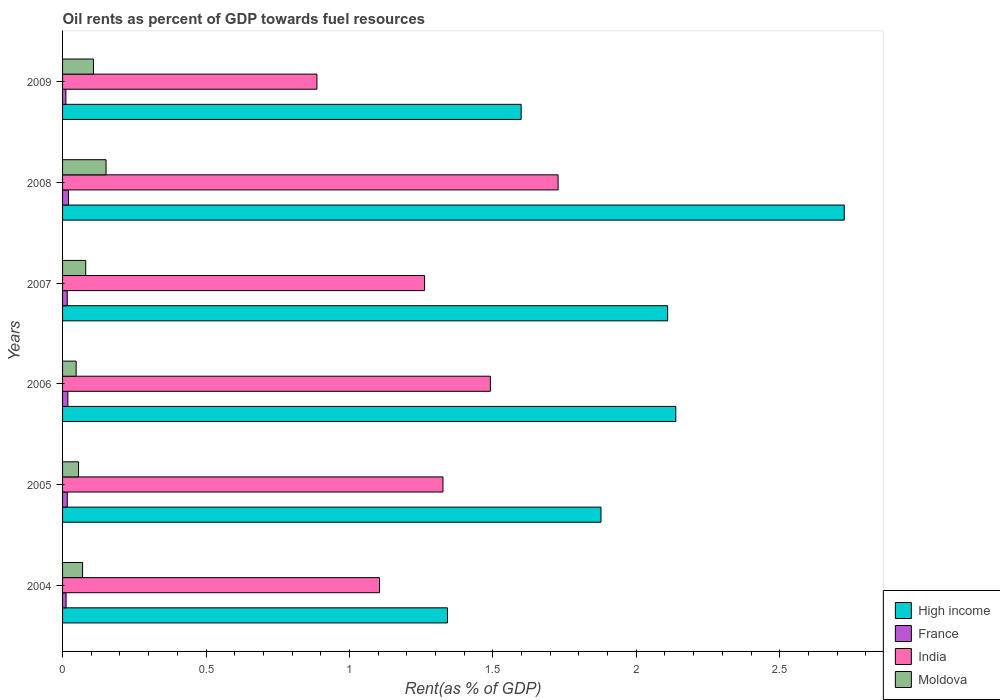Are the number of bars on each tick of the Y-axis equal?
Make the answer very short. Yes. How many bars are there on the 4th tick from the top?
Ensure brevity in your answer.  4. What is the label of the 2nd group of bars from the top?
Offer a very short reply. 2008. In how many cases, is the number of bars for a given year not equal to the number of legend labels?
Your answer should be very brief. 0. What is the oil rent in Moldova in 2004?
Ensure brevity in your answer.  0.07. Across all years, what is the maximum oil rent in Moldova?
Ensure brevity in your answer.  0.15. Across all years, what is the minimum oil rent in High income?
Offer a very short reply. 1.34. What is the total oil rent in India in the graph?
Your answer should be compact. 7.8. What is the difference between the oil rent in High income in 2007 and that in 2009?
Your answer should be very brief. 0.51. What is the difference between the oil rent in High income in 2009 and the oil rent in France in 2008?
Make the answer very short. 1.58. What is the average oil rent in Moldova per year?
Provide a short and direct response. 0.09. In the year 2006, what is the difference between the oil rent in High income and oil rent in France?
Your answer should be compact. 2.12. In how many years, is the oil rent in High income greater than 2.6 %?
Provide a short and direct response. 1. What is the ratio of the oil rent in Moldova in 2007 to that in 2008?
Provide a short and direct response. 0.53. Is the oil rent in India in 2006 less than that in 2009?
Give a very brief answer. No. What is the difference between the highest and the second highest oil rent in Moldova?
Offer a terse response. 0.04. What is the difference between the highest and the lowest oil rent in Moldova?
Your response must be concise. 0.1. Is it the case that in every year, the sum of the oil rent in India and oil rent in High income is greater than the sum of oil rent in Moldova and oil rent in France?
Your answer should be very brief. Yes. What does the 3rd bar from the top in 2009 represents?
Make the answer very short. France. Are all the bars in the graph horizontal?
Offer a very short reply. Yes. How many years are there in the graph?
Give a very brief answer. 6. What is the difference between two consecutive major ticks on the X-axis?
Ensure brevity in your answer.  0.5. Are the values on the major ticks of X-axis written in scientific E-notation?
Provide a short and direct response. No. Does the graph contain any zero values?
Offer a very short reply. No. Does the graph contain grids?
Your answer should be compact. No. How many legend labels are there?
Offer a very short reply. 4. How are the legend labels stacked?
Give a very brief answer. Vertical. What is the title of the graph?
Offer a terse response. Oil rents as percent of GDP towards fuel resources. What is the label or title of the X-axis?
Keep it short and to the point. Rent(as % of GDP). What is the label or title of the Y-axis?
Give a very brief answer. Years. What is the Rent(as % of GDP) of High income in 2004?
Your answer should be very brief. 1.34. What is the Rent(as % of GDP) of France in 2004?
Give a very brief answer. 0.01. What is the Rent(as % of GDP) in India in 2004?
Your response must be concise. 1.1. What is the Rent(as % of GDP) in Moldova in 2004?
Provide a short and direct response. 0.07. What is the Rent(as % of GDP) in High income in 2005?
Provide a succinct answer. 1.88. What is the Rent(as % of GDP) of France in 2005?
Ensure brevity in your answer.  0.02. What is the Rent(as % of GDP) of India in 2005?
Ensure brevity in your answer.  1.33. What is the Rent(as % of GDP) of Moldova in 2005?
Your response must be concise. 0.06. What is the Rent(as % of GDP) of High income in 2006?
Provide a succinct answer. 2.14. What is the Rent(as % of GDP) of France in 2006?
Your answer should be compact. 0.02. What is the Rent(as % of GDP) in India in 2006?
Provide a short and direct response. 1.49. What is the Rent(as % of GDP) in Moldova in 2006?
Ensure brevity in your answer.  0.05. What is the Rent(as % of GDP) in High income in 2007?
Offer a very short reply. 2.11. What is the Rent(as % of GDP) in France in 2007?
Provide a short and direct response. 0.02. What is the Rent(as % of GDP) of India in 2007?
Provide a succinct answer. 1.26. What is the Rent(as % of GDP) of Moldova in 2007?
Offer a terse response. 0.08. What is the Rent(as % of GDP) of High income in 2008?
Keep it short and to the point. 2.73. What is the Rent(as % of GDP) of France in 2008?
Provide a short and direct response. 0.02. What is the Rent(as % of GDP) in India in 2008?
Give a very brief answer. 1.73. What is the Rent(as % of GDP) of Moldova in 2008?
Offer a terse response. 0.15. What is the Rent(as % of GDP) in High income in 2009?
Offer a terse response. 1.6. What is the Rent(as % of GDP) of France in 2009?
Offer a very short reply. 0.01. What is the Rent(as % of GDP) in India in 2009?
Offer a very short reply. 0.89. What is the Rent(as % of GDP) of Moldova in 2009?
Your answer should be very brief. 0.11. Across all years, what is the maximum Rent(as % of GDP) of High income?
Your response must be concise. 2.73. Across all years, what is the maximum Rent(as % of GDP) in France?
Provide a succinct answer. 0.02. Across all years, what is the maximum Rent(as % of GDP) of India?
Provide a short and direct response. 1.73. Across all years, what is the maximum Rent(as % of GDP) of Moldova?
Keep it short and to the point. 0.15. Across all years, what is the minimum Rent(as % of GDP) in High income?
Make the answer very short. 1.34. Across all years, what is the minimum Rent(as % of GDP) of France?
Ensure brevity in your answer.  0.01. Across all years, what is the minimum Rent(as % of GDP) in India?
Give a very brief answer. 0.89. Across all years, what is the minimum Rent(as % of GDP) in Moldova?
Provide a succinct answer. 0.05. What is the total Rent(as % of GDP) in High income in the graph?
Your answer should be very brief. 11.79. What is the total Rent(as % of GDP) in France in the graph?
Your response must be concise. 0.1. What is the total Rent(as % of GDP) in India in the graph?
Give a very brief answer. 7.8. What is the total Rent(as % of GDP) in Moldova in the graph?
Provide a succinct answer. 0.51. What is the difference between the Rent(as % of GDP) of High income in 2004 and that in 2005?
Your answer should be compact. -0.54. What is the difference between the Rent(as % of GDP) in France in 2004 and that in 2005?
Offer a terse response. -0. What is the difference between the Rent(as % of GDP) of India in 2004 and that in 2005?
Your response must be concise. -0.22. What is the difference between the Rent(as % of GDP) of Moldova in 2004 and that in 2005?
Offer a terse response. 0.01. What is the difference between the Rent(as % of GDP) of High income in 2004 and that in 2006?
Your answer should be compact. -0.8. What is the difference between the Rent(as % of GDP) in France in 2004 and that in 2006?
Your response must be concise. -0.01. What is the difference between the Rent(as % of GDP) of India in 2004 and that in 2006?
Your answer should be very brief. -0.39. What is the difference between the Rent(as % of GDP) in Moldova in 2004 and that in 2006?
Provide a succinct answer. 0.02. What is the difference between the Rent(as % of GDP) in High income in 2004 and that in 2007?
Make the answer very short. -0.77. What is the difference between the Rent(as % of GDP) of France in 2004 and that in 2007?
Provide a short and direct response. -0. What is the difference between the Rent(as % of GDP) in India in 2004 and that in 2007?
Ensure brevity in your answer.  -0.16. What is the difference between the Rent(as % of GDP) in Moldova in 2004 and that in 2007?
Your answer should be compact. -0.01. What is the difference between the Rent(as % of GDP) of High income in 2004 and that in 2008?
Ensure brevity in your answer.  -1.38. What is the difference between the Rent(as % of GDP) of France in 2004 and that in 2008?
Your response must be concise. -0.01. What is the difference between the Rent(as % of GDP) of India in 2004 and that in 2008?
Your response must be concise. -0.62. What is the difference between the Rent(as % of GDP) in Moldova in 2004 and that in 2008?
Offer a terse response. -0.08. What is the difference between the Rent(as % of GDP) of High income in 2004 and that in 2009?
Make the answer very short. -0.26. What is the difference between the Rent(as % of GDP) of France in 2004 and that in 2009?
Offer a terse response. 0. What is the difference between the Rent(as % of GDP) in India in 2004 and that in 2009?
Your response must be concise. 0.22. What is the difference between the Rent(as % of GDP) in Moldova in 2004 and that in 2009?
Give a very brief answer. -0.04. What is the difference between the Rent(as % of GDP) of High income in 2005 and that in 2006?
Your answer should be very brief. -0.26. What is the difference between the Rent(as % of GDP) of France in 2005 and that in 2006?
Keep it short and to the point. -0. What is the difference between the Rent(as % of GDP) of India in 2005 and that in 2006?
Make the answer very short. -0.17. What is the difference between the Rent(as % of GDP) of Moldova in 2005 and that in 2006?
Offer a very short reply. 0.01. What is the difference between the Rent(as % of GDP) of High income in 2005 and that in 2007?
Offer a terse response. -0.23. What is the difference between the Rent(as % of GDP) in India in 2005 and that in 2007?
Offer a very short reply. 0.06. What is the difference between the Rent(as % of GDP) of Moldova in 2005 and that in 2007?
Give a very brief answer. -0.03. What is the difference between the Rent(as % of GDP) of High income in 2005 and that in 2008?
Your response must be concise. -0.85. What is the difference between the Rent(as % of GDP) of France in 2005 and that in 2008?
Make the answer very short. -0. What is the difference between the Rent(as % of GDP) in India in 2005 and that in 2008?
Give a very brief answer. -0.4. What is the difference between the Rent(as % of GDP) in Moldova in 2005 and that in 2008?
Make the answer very short. -0.1. What is the difference between the Rent(as % of GDP) of High income in 2005 and that in 2009?
Provide a short and direct response. 0.28. What is the difference between the Rent(as % of GDP) in France in 2005 and that in 2009?
Provide a succinct answer. 0. What is the difference between the Rent(as % of GDP) in India in 2005 and that in 2009?
Give a very brief answer. 0.44. What is the difference between the Rent(as % of GDP) of Moldova in 2005 and that in 2009?
Make the answer very short. -0.05. What is the difference between the Rent(as % of GDP) of High income in 2006 and that in 2007?
Offer a very short reply. 0.03. What is the difference between the Rent(as % of GDP) in France in 2006 and that in 2007?
Ensure brevity in your answer.  0. What is the difference between the Rent(as % of GDP) in India in 2006 and that in 2007?
Ensure brevity in your answer.  0.23. What is the difference between the Rent(as % of GDP) in Moldova in 2006 and that in 2007?
Ensure brevity in your answer.  -0.03. What is the difference between the Rent(as % of GDP) of High income in 2006 and that in 2008?
Give a very brief answer. -0.59. What is the difference between the Rent(as % of GDP) in France in 2006 and that in 2008?
Offer a very short reply. -0. What is the difference between the Rent(as % of GDP) of India in 2006 and that in 2008?
Your answer should be very brief. -0.24. What is the difference between the Rent(as % of GDP) in Moldova in 2006 and that in 2008?
Your response must be concise. -0.1. What is the difference between the Rent(as % of GDP) in High income in 2006 and that in 2009?
Your response must be concise. 0.54. What is the difference between the Rent(as % of GDP) in France in 2006 and that in 2009?
Your response must be concise. 0.01. What is the difference between the Rent(as % of GDP) in India in 2006 and that in 2009?
Offer a very short reply. 0.6. What is the difference between the Rent(as % of GDP) in Moldova in 2006 and that in 2009?
Your answer should be compact. -0.06. What is the difference between the Rent(as % of GDP) of High income in 2007 and that in 2008?
Offer a very short reply. -0.62. What is the difference between the Rent(as % of GDP) in France in 2007 and that in 2008?
Your answer should be compact. -0. What is the difference between the Rent(as % of GDP) in India in 2007 and that in 2008?
Offer a terse response. -0.47. What is the difference between the Rent(as % of GDP) in Moldova in 2007 and that in 2008?
Your answer should be very brief. -0.07. What is the difference between the Rent(as % of GDP) in High income in 2007 and that in 2009?
Your answer should be compact. 0.51. What is the difference between the Rent(as % of GDP) of France in 2007 and that in 2009?
Provide a short and direct response. 0. What is the difference between the Rent(as % of GDP) of India in 2007 and that in 2009?
Offer a terse response. 0.38. What is the difference between the Rent(as % of GDP) of Moldova in 2007 and that in 2009?
Provide a short and direct response. -0.03. What is the difference between the Rent(as % of GDP) in High income in 2008 and that in 2009?
Your response must be concise. 1.13. What is the difference between the Rent(as % of GDP) of France in 2008 and that in 2009?
Provide a short and direct response. 0.01. What is the difference between the Rent(as % of GDP) in India in 2008 and that in 2009?
Ensure brevity in your answer.  0.84. What is the difference between the Rent(as % of GDP) of Moldova in 2008 and that in 2009?
Your response must be concise. 0.04. What is the difference between the Rent(as % of GDP) of High income in 2004 and the Rent(as % of GDP) of France in 2005?
Ensure brevity in your answer.  1.33. What is the difference between the Rent(as % of GDP) of High income in 2004 and the Rent(as % of GDP) of India in 2005?
Keep it short and to the point. 0.02. What is the difference between the Rent(as % of GDP) in High income in 2004 and the Rent(as % of GDP) in Moldova in 2005?
Your answer should be very brief. 1.29. What is the difference between the Rent(as % of GDP) in France in 2004 and the Rent(as % of GDP) in India in 2005?
Your answer should be very brief. -1.31. What is the difference between the Rent(as % of GDP) of France in 2004 and the Rent(as % of GDP) of Moldova in 2005?
Your answer should be very brief. -0.04. What is the difference between the Rent(as % of GDP) in India in 2004 and the Rent(as % of GDP) in Moldova in 2005?
Ensure brevity in your answer.  1.05. What is the difference between the Rent(as % of GDP) of High income in 2004 and the Rent(as % of GDP) of France in 2006?
Offer a very short reply. 1.32. What is the difference between the Rent(as % of GDP) in High income in 2004 and the Rent(as % of GDP) in India in 2006?
Keep it short and to the point. -0.15. What is the difference between the Rent(as % of GDP) in High income in 2004 and the Rent(as % of GDP) in Moldova in 2006?
Your response must be concise. 1.29. What is the difference between the Rent(as % of GDP) of France in 2004 and the Rent(as % of GDP) of India in 2006?
Keep it short and to the point. -1.48. What is the difference between the Rent(as % of GDP) of France in 2004 and the Rent(as % of GDP) of Moldova in 2006?
Keep it short and to the point. -0.04. What is the difference between the Rent(as % of GDP) in India in 2004 and the Rent(as % of GDP) in Moldova in 2006?
Your answer should be very brief. 1.06. What is the difference between the Rent(as % of GDP) in High income in 2004 and the Rent(as % of GDP) in France in 2007?
Your response must be concise. 1.33. What is the difference between the Rent(as % of GDP) in High income in 2004 and the Rent(as % of GDP) in India in 2007?
Ensure brevity in your answer.  0.08. What is the difference between the Rent(as % of GDP) of High income in 2004 and the Rent(as % of GDP) of Moldova in 2007?
Ensure brevity in your answer.  1.26. What is the difference between the Rent(as % of GDP) in France in 2004 and the Rent(as % of GDP) in India in 2007?
Give a very brief answer. -1.25. What is the difference between the Rent(as % of GDP) in France in 2004 and the Rent(as % of GDP) in Moldova in 2007?
Your response must be concise. -0.07. What is the difference between the Rent(as % of GDP) of India in 2004 and the Rent(as % of GDP) of Moldova in 2007?
Provide a succinct answer. 1.02. What is the difference between the Rent(as % of GDP) of High income in 2004 and the Rent(as % of GDP) of France in 2008?
Keep it short and to the point. 1.32. What is the difference between the Rent(as % of GDP) of High income in 2004 and the Rent(as % of GDP) of India in 2008?
Keep it short and to the point. -0.39. What is the difference between the Rent(as % of GDP) of High income in 2004 and the Rent(as % of GDP) of Moldova in 2008?
Keep it short and to the point. 1.19. What is the difference between the Rent(as % of GDP) of France in 2004 and the Rent(as % of GDP) of India in 2008?
Provide a succinct answer. -1.72. What is the difference between the Rent(as % of GDP) of France in 2004 and the Rent(as % of GDP) of Moldova in 2008?
Offer a terse response. -0.14. What is the difference between the Rent(as % of GDP) in India in 2004 and the Rent(as % of GDP) in Moldova in 2008?
Keep it short and to the point. 0.95. What is the difference between the Rent(as % of GDP) of High income in 2004 and the Rent(as % of GDP) of France in 2009?
Give a very brief answer. 1.33. What is the difference between the Rent(as % of GDP) in High income in 2004 and the Rent(as % of GDP) in India in 2009?
Offer a very short reply. 0.46. What is the difference between the Rent(as % of GDP) of High income in 2004 and the Rent(as % of GDP) of Moldova in 2009?
Provide a succinct answer. 1.23. What is the difference between the Rent(as % of GDP) in France in 2004 and the Rent(as % of GDP) in India in 2009?
Offer a terse response. -0.87. What is the difference between the Rent(as % of GDP) of France in 2004 and the Rent(as % of GDP) of Moldova in 2009?
Provide a succinct answer. -0.1. What is the difference between the Rent(as % of GDP) of India in 2004 and the Rent(as % of GDP) of Moldova in 2009?
Your answer should be very brief. 1. What is the difference between the Rent(as % of GDP) of High income in 2005 and the Rent(as % of GDP) of France in 2006?
Ensure brevity in your answer.  1.86. What is the difference between the Rent(as % of GDP) in High income in 2005 and the Rent(as % of GDP) in India in 2006?
Make the answer very short. 0.39. What is the difference between the Rent(as % of GDP) in High income in 2005 and the Rent(as % of GDP) in Moldova in 2006?
Your response must be concise. 1.83. What is the difference between the Rent(as % of GDP) in France in 2005 and the Rent(as % of GDP) in India in 2006?
Provide a short and direct response. -1.47. What is the difference between the Rent(as % of GDP) in France in 2005 and the Rent(as % of GDP) in Moldova in 2006?
Ensure brevity in your answer.  -0.03. What is the difference between the Rent(as % of GDP) of India in 2005 and the Rent(as % of GDP) of Moldova in 2006?
Your response must be concise. 1.28. What is the difference between the Rent(as % of GDP) of High income in 2005 and the Rent(as % of GDP) of France in 2007?
Your answer should be very brief. 1.86. What is the difference between the Rent(as % of GDP) in High income in 2005 and the Rent(as % of GDP) in India in 2007?
Provide a succinct answer. 0.61. What is the difference between the Rent(as % of GDP) in High income in 2005 and the Rent(as % of GDP) in Moldova in 2007?
Keep it short and to the point. 1.8. What is the difference between the Rent(as % of GDP) of France in 2005 and the Rent(as % of GDP) of India in 2007?
Provide a succinct answer. -1.25. What is the difference between the Rent(as % of GDP) in France in 2005 and the Rent(as % of GDP) in Moldova in 2007?
Offer a terse response. -0.06. What is the difference between the Rent(as % of GDP) of India in 2005 and the Rent(as % of GDP) of Moldova in 2007?
Your answer should be very brief. 1.25. What is the difference between the Rent(as % of GDP) in High income in 2005 and the Rent(as % of GDP) in France in 2008?
Keep it short and to the point. 1.86. What is the difference between the Rent(as % of GDP) in High income in 2005 and the Rent(as % of GDP) in India in 2008?
Your response must be concise. 0.15. What is the difference between the Rent(as % of GDP) in High income in 2005 and the Rent(as % of GDP) in Moldova in 2008?
Your response must be concise. 1.73. What is the difference between the Rent(as % of GDP) of France in 2005 and the Rent(as % of GDP) of India in 2008?
Offer a terse response. -1.71. What is the difference between the Rent(as % of GDP) in France in 2005 and the Rent(as % of GDP) in Moldova in 2008?
Offer a very short reply. -0.14. What is the difference between the Rent(as % of GDP) of India in 2005 and the Rent(as % of GDP) of Moldova in 2008?
Provide a succinct answer. 1.17. What is the difference between the Rent(as % of GDP) in High income in 2005 and the Rent(as % of GDP) in France in 2009?
Offer a very short reply. 1.87. What is the difference between the Rent(as % of GDP) in High income in 2005 and the Rent(as % of GDP) in India in 2009?
Ensure brevity in your answer.  0.99. What is the difference between the Rent(as % of GDP) of High income in 2005 and the Rent(as % of GDP) of Moldova in 2009?
Your response must be concise. 1.77. What is the difference between the Rent(as % of GDP) of France in 2005 and the Rent(as % of GDP) of India in 2009?
Your answer should be compact. -0.87. What is the difference between the Rent(as % of GDP) of France in 2005 and the Rent(as % of GDP) of Moldova in 2009?
Ensure brevity in your answer.  -0.09. What is the difference between the Rent(as % of GDP) in India in 2005 and the Rent(as % of GDP) in Moldova in 2009?
Make the answer very short. 1.22. What is the difference between the Rent(as % of GDP) of High income in 2006 and the Rent(as % of GDP) of France in 2007?
Your response must be concise. 2.12. What is the difference between the Rent(as % of GDP) of High income in 2006 and the Rent(as % of GDP) of India in 2007?
Your answer should be compact. 0.88. What is the difference between the Rent(as % of GDP) in High income in 2006 and the Rent(as % of GDP) in Moldova in 2007?
Keep it short and to the point. 2.06. What is the difference between the Rent(as % of GDP) in France in 2006 and the Rent(as % of GDP) in India in 2007?
Provide a short and direct response. -1.24. What is the difference between the Rent(as % of GDP) in France in 2006 and the Rent(as % of GDP) in Moldova in 2007?
Provide a succinct answer. -0.06. What is the difference between the Rent(as % of GDP) of India in 2006 and the Rent(as % of GDP) of Moldova in 2007?
Your answer should be compact. 1.41. What is the difference between the Rent(as % of GDP) in High income in 2006 and the Rent(as % of GDP) in France in 2008?
Your answer should be compact. 2.12. What is the difference between the Rent(as % of GDP) in High income in 2006 and the Rent(as % of GDP) in India in 2008?
Offer a very short reply. 0.41. What is the difference between the Rent(as % of GDP) of High income in 2006 and the Rent(as % of GDP) of Moldova in 2008?
Offer a terse response. 1.99. What is the difference between the Rent(as % of GDP) in France in 2006 and the Rent(as % of GDP) in India in 2008?
Offer a terse response. -1.71. What is the difference between the Rent(as % of GDP) of France in 2006 and the Rent(as % of GDP) of Moldova in 2008?
Ensure brevity in your answer.  -0.13. What is the difference between the Rent(as % of GDP) of India in 2006 and the Rent(as % of GDP) of Moldova in 2008?
Offer a terse response. 1.34. What is the difference between the Rent(as % of GDP) in High income in 2006 and the Rent(as % of GDP) in France in 2009?
Offer a terse response. 2.13. What is the difference between the Rent(as % of GDP) in High income in 2006 and the Rent(as % of GDP) in India in 2009?
Provide a succinct answer. 1.25. What is the difference between the Rent(as % of GDP) of High income in 2006 and the Rent(as % of GDP) of Moldova in 2009?
Offer a terse response. 2.03. What is the difference between the Rent(as % of GDP) in France in 2006 and the Rent(as % of GDP) in India in 2009?
Ensure brevity in your answer.  -0.87. What is the difference between the Rent(as % of GDP) in France in 2006 and the Rent(as % of GDP) in Moldova in 2009?
Provide a succinct answer. -0.09. What is the difference between the Rent(as % of GDP) of India in 2006 and the Rent(as % of GDP) of Moldova in 2009?
Provide a succinct answer. 1.38. What is the difference between the Rent(as % of GDP) in High income in 2007 and the Rent(as % of GDP) in France in 2008?
Offer a terse response. 2.09. What is the difference between the Rent(as % of GDP) in High income in 2007 and the Rent(as % of GDP) in India in 2008?
Offer a very short reply. 0.38. What is the difference between the Rent(as % of GDP) of High income in 2007 and the Rent(as % of GDP) of Moldova in 2008?
Your answer should be very brief. 1.96. What is the difference between the Rent(as % of GDP) of France in 2007 and the Rent(as % of GDP) of India in 2008?
Your response must be concise. -1.71. What is the difference between the Rent(as % of GDP) of France in 2007 and the Rent(as % of GDP) of Moldova in 2008?
Offer a very short reply. -0.14. What is the difference between the Rent(as % of GDP) in India in 2007 and the Rent(as % of GDP) in Moldova in 2008?
Your response must be concise. 1.11. What is the difference between the Rent(as % of GDP) of High income in 2007 and the Rent(as % of GDP) of France in 2009?
Make the answer very short. 2.1. What is the difference between the Rent(as % of GDP) of High income in 2007 and the Rent(as % of GDP) of India in 2009?
Keep it short and to the point. 1.22. What is the difference between the Rent(as % of GDP) of High income in 2007 and the Rent(as % of GDP) of Moldova in 2009?
Offer a terse response. 2. What is the difference between the Rent(as % of GDP) in France in 2007 and the Rent(as % of GDP) in India in 2009?
Provide a short and direct response. -0.87. What is the difference between the Rent(as % of GDP) of France in 2007 and the Rent(as % of GDP) of Moldova in 2009?
Offer a very short reply. -0.09. What is the difference between the Rent(as % of GDP) in India in 2007 and the Rent(as % of GDP) in Moldova in 2009?
Provide a short and direct response. 1.15. What is the difference between the Rent(as % of GDP) in High income in 2008 and the Rent(as % of GDP) in France in 2009?
Offer a very short reply. 2.71. What is the difference between the Rent(as % of GDP) in High income in 2008 and the Rent(as % of GDP) in India in 2009?
Give a very brief answer. 1.84. What is the difference between the Rent(as % of GDP) in High income in 2008 and the Rent(as % of GDP) in Moldova in 2009?
Provide a succinct answer. 2.62. What is the difference between the Rent(as % of GDP) in France in 2008 and the Rent(as % of GDP) in India in 2009?
Offer a very short reply. -0.87. What is the difference between the Rent(as % of GDP) in France in 2008 and the Rent(as % of GDP) in Moldova in 2009?
Your answer should be compact. -0.09. What is the difference between the Rent(as % of GDP) of India in 2008 and the Rent(as % of GDP) of Moldova in 2009?
Keep it short and to the point. 1.62. What is the average Rent(as % of GDP) of High income per year?
Ensure brevity in your answer.  1.96. What is the average Rent(as % of GDP) of France per year?
Offer a very short reply. 0.02. What is the average Rent(as % of GDP) in India per year?
Your response must be concise. 1.3. What is the average Rent(as % of GDP) of Moldova per year?
Offer a terse response. 0.09. In the year 2004, what is the difference between the Rent(as % of GDP) of High income and Rent(as % of GDP) of France?
Ensure brevity in your answer.  1.33. In the year 2004, what is the difference between the Rent(as % of GDP) of High income and Rent(as % of GDP) of India?
Offer a terse response. 0.24. In the year 2004, what is the difference between the Rent(as % of GDP) of High income and Rent(as % of GDP) of Moldova?
Provide a succinct answer. 1.27. In the year 2004, what is the difference between the Rent(as % of GDP) of France and Rent(as % of GDP) of India?
Offer a terse response. -1.09. In the year 2004, what is the difference between the Rent(as % of GDP) of France and Rent(as % of GDP) of Moldova?
Give a very brief answer. -0.06. In the year 2004, what is the difference between the Rent(as % of GDP) of India and Rent(as % of GDP) of Moldova?
Give a very brief answer. 1.04. In the year 2005, what is the difference between the Rent(as % of GDP) in High income and Rent(as % of GDP) in France?
Offer a terse response. 1.86. In the year 2005, what is the difference between the Rent(as % of GDP) in High income and Rent(as % of GDP) in India?
Make the answer very short. 0.55. In the year 2005, what is the difference between the Rent(as % of GDP) in High income and Rent(as % of GDP) in Moldova?
Offer a terse response. 1.82. In the year 2005, what is the difference between the Rent(as % of GDP) of France and Rent(as % of GDP) of India?
Give a very brief answer. -1.31. In the year 2005, what is the difference between the Rent(as % of GDP) of France and Rent(as % of GDP) of Moldova?
Your answer should be compact. -0.04. In the year 2005, what is the difference between the Rent(as % of GDP) in India and Rent(as % of GDP) in Moldova?
Offer a very short reply. 1.27. In the year 2006, what is the difference between the Rent(as % of GDP) of High income and Rent(as % of GDP) of France?
Provide a short and direct response. 2.12. In the year 2006, what is the difference between the Rent(as % of GDP) of High income and Rent(as % of GDP) of India?
Ensure brevity in your answer.  0.65. In the year 2006, what is the difference between the Rent(as % of GDP) in High income and Rent(as % of GDP) in Moldova?
Give a very brief answer. 2.09. In the year 2006, what is the difference between the Rent(as % of GDP) of France and Rent(as % of GDP) of India?
Your response must be concise. -1.47. In the year 2006, what is the difference between the Rent(as % of GDP) in France and Rent(as % of GDP) in Moldova?
Ensure brevity in your answer.  -0.03. In the year 2006, what is the difference between the Rent(as % of GDP) of India and Rent(as % of GDP) of Moldova?
Provide a short and direct response. 1.44. In the year 2007, what is the difference between the Rent(as % of GDP) of High income and Rent(as % of GDP) of France?
Your answer should be compact. 2.09. In the year 2007, what is the difference between the Rent(as % of GDP) of High income and Rent(as % of GDP) of India?
Make the answer very short. 0.85. In the year 2007, what is the difference between the Rent(as % of GDP) in High income and Rent(as % of GDP) in Moldova?
Keep it short and to the point. 2.03. In the year 2007, what is the difference between the Rent(as % of GDP) of France and Rent(as % of GDP) of India?
Make the answer very short. -1.25. In the year 2007, what is the difference between the Rent(as % of GDP) of France and Rent(as % of GDP) of Moldova?
Ensure brevity in your answer.  -0.06. In the year 2007, what is the difference between the Rent(as % of GDP) of India and Rent(as % of GDP) of Moldova?
Ensure brevity in your answer.  1.18. In the year 2008, what is the difference between the Rent(as % of GDP) of High income and Rent(as % of GDP) of France?
Your response must be concise. 2.7. In the year 2008, what is the difference between the Rent(as % of GDP) of High income and Rent(as % of GDP) of India?
Your answer should be compact. 1. In the year 2008, what is the difference between the Rent(as % of GDP) in High income and Rent(as % of GDP) in Moldova?
Your answer should be compact. 2.57. In the year 2008, what is the difference between the Rent(as % of GDP) of France and Rent(as % of GDP) of India?
Keep it short and to the point. -1.71. In the year 2008, what is the difference between the Rent(as % of GDP) in France and Rent(as % of GDP) in Moldova?
Offer a very short reply. -0.13. In the year 2008, what is the difference between the Rent(as % of GDP) of India and Rent(as % of GDP) of Moldova?
Ensure brevity in your answer.  1.58. In the year 2009, what is the difference between the Rent(as % of GDP) of High income and Rent(as % of GDP) of France?
Ensure brevity in your answer.  1.59. In the year 2009, what is the difference between the Rent(as % of GDP) of High income and Rent(as % of GDP) of India?
Provide a short and direct response. 0.71. In the year 2009, what is the difference between the Rent(as % of GDP) of High income and Rent(as % of GDP) of Moldova?
Offer a terse response. 1.49. In the year 2009, what is the difference between the Rent(as % of GDP) of France and Rent(as % of GDP) of India?
Offer a terse response. -0.88. In the year 2009, what is the difference between the Rent(as % of GDP) of France and Rent(as % of GDP) of Moldova?
Offer a very short reply. -0.1. In the year 2009, what is the difference between the Rent(as % of GDP) of India and Rent(as % of GDP) of Moldova?
Ensure brevity in your answer.  0.78. What is the ratio of the Rent(as % of GDP) of High income in 2004 to that in 2005?
Your answer should be compact. 0.71. What is the ratio of the Rent(as % of GDP) of France in 2004 to that in 2005?
Ensure brevity in your answer.  0.74. What is the ratio of the Rent(as % of GDP) of India in 2004 to that in 2005?
Offer a very short reply. 0.83. What is the ratio of the Rent(as % of GDP) of Moldova in 2004 to that in 2005?
Keep it short and to the point. 1.25. What is the ratio of the Rent(as % of GDP) in High income in 2004 to that in 2006?
Ensure brevity in your answer.  0.63. What is the ratio of the Rent(as % of GDP) of France in 2004 to that in 2006?
Ensure brevity in your answer.  0.66. What is the ratio of the Rent(as % of GDP) of India in 2004 to that in 2006?
Give a very brief answer. 0.74. What is the ratio of the Rent(as % of GDP) of Moldova in 2004 to that in 2006?
Offer a terse response. 1.47. What is the ratio of the Rent(as % of GDP) in High income in 2004 to that in 2007?
Ensure brevity in your answer.  0.64. What is the ratio of the Rent(as % of GDP) of France in 2004 to that in 2007?
Provide a short and direct response. 0.75. What is the ratio of the Rent(as % of GDP) of India in 2004 to that in 2007?
Provide a short and direct response. 0.88. What is the ratio of the Rent(as % of GDP) in Moldova in 2004 to that in 2007?
Provide a short and direct response. 0.86. What is the ratio of the Rent(as % of GDP) in High income in 2004 to that in 2008?
Provide a short and direct response. 0.49. What is the ratio of the Rent(as % of GDP) of France in 2004 to that in 2008?
Provide a succinct answer. 0.59. What is the ratio of the Rent(as % of GDP) of India in 2004 to that in 2008?
Make the answer very short. 0.64. What is the ratio of the Rent(as % of GDP) in Moldova in 2004 to that in 2008?
Provide a succinct answer. 0.46. What is the ratio of the Rent(as % of GDP) in High income in 2004 to that in 2009?
Offer a terse response. 0.84. What is the ratio of the Rent(as % of GDP) of France in 2004 to that in 2009?
Give a very brief answer. 1.06. What is the ratio of the Rent(as % of GDP) of India in 2004 to that in 2009?
Your answer should be very brief. 1.25. What is the ratio of the Rent(as % of GDP) of Moldova in 2004 to that in 2009?
Keep it short and to the point. 0.65. What is the ratio of the Rent(as % of GDP) of High income in 2005 to that in 2006?
Provide a succinct answer. 0.88. What is the ratio of the Rent(as % of GDP) of France in 2005 to that in 2006?
Ensure brevity in your answer.  0.89. What is the ratio of the Rent(as % of GDP) in India in 2005 to that in 2006?
Your answer should be very brief. 0.89. What is the ratio of the Rent(as % of GDP) of Moldova in 2005 to that in 2006?
Make the answer very short. 1.18. What is the ratio of the Rent(as % of GDP) in High income in 2005 to that in 2007?
Keep it short and to the point. 0.89. What is the ratio of the Rent(as % of GDP) in France in 2005 to that in 2007?
Offer a terse response. 1. What is the ratio of the Rent(as % of GDP) in India in 2005 to that in 2007?
Give a very brief answer. 1.05. What is the ratio of the Rent(as % of GDP) in Moldova in 2005 to that in 2007?
Your answer should be very brief. 0.69. What is the ratio of the Rent(as % of GDP) of High income in 2005 to that in 2008?
Your answer should be very brief. 0.69. What is the ratio of the Rent(as % of GDP) in France in 2005 to that in 2008?
Keep it short and to the point. 0.8. What is the ratio of the Rent(as % of GDP) in India in 2005 to that in 2008?
Provide a succinct answer. 0.77. What is the ratio of the Rent(as % of GDP) in Moldova in 2005 to that in 2008?
Make the answer very short. 0.37. What is the ratio of the Rent(as % of GDP) in High income in 2005 to that in 2009?
Offer a very short reply. 1.17. What is the ratio of the Rent(as % of GDP) in France in 2005 to that in 2009?
Your answer should be compact. 1.42. What is the ratio of the Rent(as % of GDP) of India in 2005 to that in 2009?
Your answer should be compact. 1.5. What is the ratio of the Rent(as % of GDP) of Moldova in 2005 to that in 2009?
Ensure brevity in your answer.  0.52. What is the ratio of the Rent(as % of GDP) of High income in 2006 to that in 2007?
Your response must be concise. 1.01. What is the ratio of the Rent(as % of GDP) of France in 2006 to that in 2007?
Your answer should be compact. 1.13. What is the ratio of the Rent(as % of GDP) in India in 2006 to that in 2007?
Ensure brevity in your answer.  1.18. What is the ratio of the Rent(as % of GDP) of Moldova in 2006 to that in 2007?
Keep it short and to the point. 0.59. What is the ratio of the Rent(as % of GDP) in High income in 2006 to that in 2008?
Ensure brevity in your answer.  0.78. What is the ratio of the Rent(as % of GDP) of France in 2006 to that in 2008?
Provide a succinct answer. 0.9. What is the ratio of the Rent(as % of GDP) of India in 2006 to that in 2008?
Provide a succinct answer. 0.86. What is the ratio of the Rent(as % of GDP) of Moldova in 2006 to that in 2008?
Your answer should be very brief. 0.31. What is the ratio of the Rent(as % of GDP) of High income in 2006 to that in 2009?
Make the answer very short. 1.34. What is the ratio of the Rent(as % of GDP) in France in 2006 to that in 2009?
Provide a succinct answer. 1.59. What is the ratio of the Rent(as % of GDP) in India in 2006 to that in 2009?
Provide a short and direct response. 1.68. What is the ratio of the Rent(as % of GDP) of Moldova in 2006 to that in 2009?
Keep it short and to the point. 0.44. What is the ratio of the Rent(as % of GDP) in High income in 2007 to that in 2008?
Ensure brevity in your answer.  0.77. What is the ratio of the Rent(as % of GDP) of France in 2007 to that in 2008?
Keep it short and to the point. 0.8. What is the ratio of the Rent(as % of GDP) in India in 2007 to that in 2008?
Keep it short and to the point. 0.73. What is the ratio of the Rent(as % of GDP) in Moldova in 2007 to that in 2008?
Offer a very short reply. 0.53. What is the ratio of the Rent(as % of GDP) of High income in 2007 to that in 2009?
Make the answer very short. 1.32. What is the ratio of the Rent(as % of GDP) in France in 2007 to that in 2009?
Provide a short and direct response. 1.41. What is the ratio of the Rent(as % of GDP) of India in 2007 to that in 2009?
Provide a short and direct response. 1.42. What is the ratio of the Rent(as % of GDP) in Moldova in 2007 to that in 2009?
Give a very brief answer. 0.75. What is the ratio of the Rent(as % of GDP) in High income in 2008 to that in 2009?
Keep it short and to the point. 1.7. What is the ratio of the Rent(as % of GDP) in France in 2008 to that in 2009?
Provide a succinct answer. 1.77. What is the ratio of the Rent(as % of GDP) of India in 2008 to that in 2009?
Provide a succinct answer. 1.95. What is the ratio of the Rent(as % of GDP) of Moldova in 2008 to that in 2009?
Ensure brevity in your answer.  1.41. What is the difference between the highest and the second highest Rent(as % of GDP) in High income?
Your answer should be compact. 0.59. What is the difference between the highest and the second highest Rent(as % of GDP) of France?
Keep it short and to the point. 0. What is the difference between the highest and the second highest Rent(as % of GDP) of India?
Make the answer very short. 0.24. What is the difference between the highest and the second highest Rent(as % of GDP) in Moldova?
Provide a short and direct response. 0.04. What is the difference between the highest and the lowest Rent(as % of GDP) in High income?
Offer a terse response. 1.38. What is the difference between the highest and the lowest Rent(as % of GDP) in France?
Make the answer very short. 0.01. What is the difference between the highest and the lowest Rent(as % of GDP) in India?
Give a very brief answer. 0.84. What is the difference between the highest and the lowest Rent(as % of GDP) of Moldova?
Ensure brevity in your answer.  0.1. 